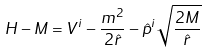<formula> <loc_0><loc_0><loc_500><loc_500>H - M = V ^ { i } - \frac { m ^ { 2 } } { 2 \hat { r } } - \hat { p } ^ { i } \sqrt { \frac { 2 M } { \hat { r } } }</formula> 